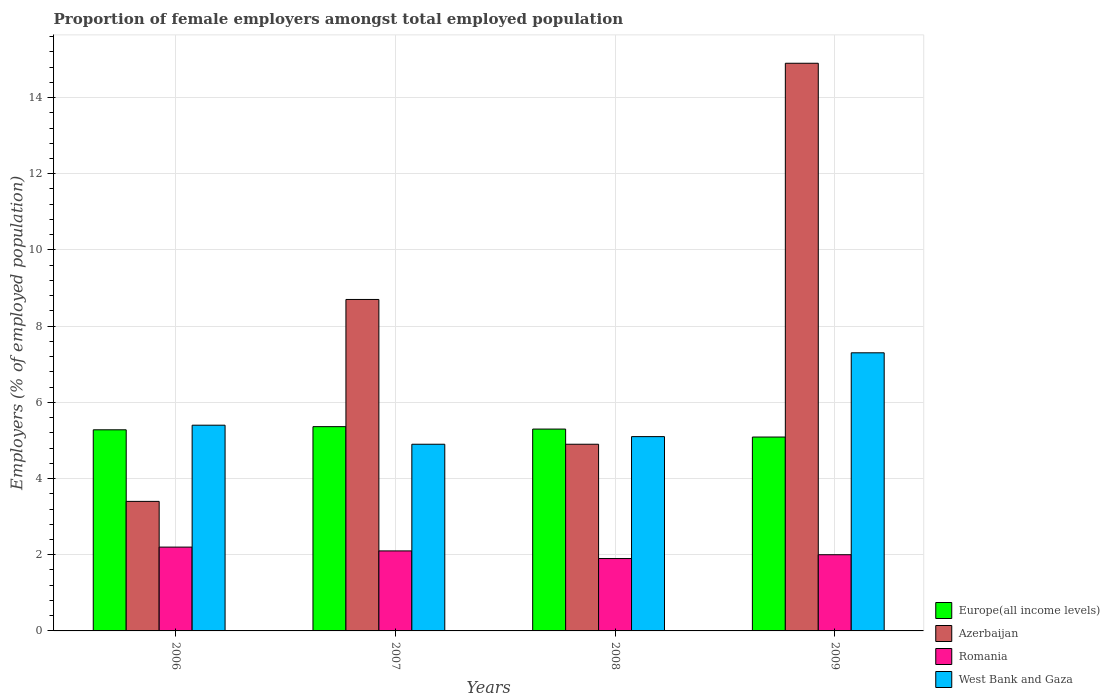How many different coloured bars are there?
Give a very brief answer. 4. How many groups of bars are there?
Keep it short and to the point. 4. How many bars are there on the 1st tick from the left?
Your answer should be very brief. 4. How many bars are there on the 4th tick from the right?
Give a very brief answer. 4. What is the label of the 1st group of bars from the left?
Ensure brevity in your answer.  2006. In how many cases, is the number of bars for a given year not equal to the number of legend labels?
Provide a short and direct response. 0. What is the proportion of female employers in Azerbaijan in 2008?
Ensure brevity in your answer.  4.9. Across all years, what is the maximum proportion of female employers in Azerbaijan?
Ensure brevity in your answer.  14.9. Across all years, what is the minimum proportion of female employers in Romania?
Make the answer very short. 1.9. In which year was the proportion of female employers in Europe(all income levels) minimum?
Your response must be concise. 2009. What is the total proportion of female employers in Europe(all income levels) in the graph?
Ensure brevity in your answer.  21.03. What is the difference between the proportion of female employers in West Bank and Gaza in 2007 and that in 2009?
Offer a very short reply. -2.4. What is the difference between the proportion of female employers in Romania in 2008 and the proportion of female employers in West Bank and Gaza in 2009?
Keep it short and to the point. -5.4. What is the average proportion of female employers in Europe(all income levels) per year?
Your response must be concise. 5.26. In the year 2006, what is the difference between the proportion of female employers in Romania and proportion of female employers in Europe(all income levels)?
Provide a succinct answer. -3.08. What is the ratio of the proportion of female employers in Romania in 2006 to that in 2007?
Keep it short and to the point. 1.05. What is the difference between the highest and the second highest proportion of female employers in Europe(all income levels)?
Your answer should be very brief. 0.06. What is the difference between the highest and the lowest proportion of female employers in West Bank and Gaza?
Keep it short and to the point. 2.4. In how many years, is the proportion of female employers in West Bank and Gaza greater than the average proportion of female employers in West Bank and Gaza taken over all years?
Keep it short and to the point. 1. Is the sum of the proportion of female employers in Azerbaijan in 2006 and 2009 greater than the maximum proportion of female employers in West Bank and Gaza across all years?
Make the answer very short. Yes. Is it the case that in every year, the sum of the proportion of female employers in West Bank and Gaza and proportion of female employers in Europe(all income levels) is greater than the sum of proportion of female employers in Romania and proportion of female employers in Azerbaijan?
Provide a succinct answer. No. What does the 1st bar from the left in 2006 represents?
Provide a succinct answer. Europe(all income levels). What does the 2nd bar from the right in 2007 represents?
Offer a terse response. Romania. How many bars are there?
Ensure brevity in your answer.  16. How many years are there in the graph?
Provide a short and direct response. 4. What is the difference between two consecutive major ticks on the Y-axis?
Provide a succinct answer. 2. Are the values on the major ticks of Y-axis written in scientific E-notation?
Your answer should be compact. No. Does the graph contain any zero values?
Your answer should be compact. No. Does the graph contain grids?
Provide a short and direct response. Yes. How many legend labels are there?
Your answer should be compact. 4. How are the legend labels stacked?
Ensure brevity in your answer.  Vertical. What is the title of the graph?
Your answer should be compact. Proportion of female employers amongst total employed population. What is the label or title of the X-axis?
Your answer should be very brief. Years. What is the label or title of the Y-axis?
Offer a very short reply. Employers (% of employed population). What is the Employers (% of employed population) of Europe(all income levels) in 2006?
Provide a short and direct response. 5.28. What is the Employers (% of employed population) of Azerbaijan in 2006?
Ensure brevity in your answer.  3.4. What is the Employers (% of employed population) of Romania in 2006?
Give a very brief answer. 2.2. What is the Employers (% of employed population) in West Bank and Gaza in 2006?
Keep it short and to the point. 5.4. What is the Employers (% of employed population) of Europe(all income levels) in 2007?
Offer a terse response. 5.36. What is the Employers (% of employed population) in Azerbaijan in 2007?
Your response must be concise. 8.7. What is the Employers (% of employed population) of Romania in 2007?
Your answer should be very brief. 2.1. What is the Employers (% of employed population) of West Bank and Gaza in 2007?
Ensure brevity in your answer.  4.9. What is the Employers (% of employed population) in Europe(all income levels) in 2008?
Offer a terse response. 5.3. What is the Employers (% of employed population) of Azerbaijan in 2008?
Give a very brief answer. 4.9. What is the Employers (% of employed population) of Romania in 2008?
Ensure brevity in your answer.  1.9. What is the Employers (% of employed population) in West Bank and Gaza in 2008?
Offer a terse response. 5.1. What is the Employers (% of employed population) in Europe(all income levels) in 2009?
Your answer should be very brief. 5.09. What is the Employers (% of employed population) of Azerbaijan in 2009?
Offer a very short reply. 14.9. What is the Employers (% of employed population) of Romania in 2009?
Provide a short and direct response. 2. What is the Employers (% of employed population) in West Bank and Gaza in 2009?
Ensure brevity in your answer.  7.3. Across all years, what is the maximum Employers (% of employed population) of Europe(all income levels)?
Ensure brevity in your answer.  5.36. Across all years, what is the maximum Employers (% of employed population) of Azerbaijan?
Keep it short and to the point. 14.9. Across all years, what is the maximum Employers (% of employed population) in Romania?
Your answer should be compact. 2.2. Across all years, what is the maximum Employers (% of employed population) in West Bank and Gaza?
Your response must be concise. 7.3. Across all years, what is the minimum Employers (% of employed population) in Europe(all income levels)?
Your answer should be compact. 5.09. Across all years, what is the minimum Employers (% of employed population) of Azerbaijan?
Give a very brief answer. 3.4. Across all years, what is the minimum Employers (% of employed population) in Romania?
Ensure brevity in your answer.  1.9. Across all years, what is the minimum Employers (% of employed population) of West Bank and Gaza?
Offer a terse response. 4.9. What is the total Employers (% of employed population) of Europe(all income levels) in the graph?
Provide a short and direct response. 21.03. What is the total Employers (% of employed population) in Azerbaijan in the graph?
Make the answer very short. 31.9. What is the total Employers (% of employed population) in Romania in the graph?
Your response must be concise. 8.2. What is the total Employers (% of employed population) of West Bank and Gaza in the graph?
Provide a succinct answer. 22.7. What is the difference between the Employers (% of employed population) in Europe(all income levels) in 2006 and that in 2007?
Keep it short and to the point. -0.08. What is the difference between the Employers (% of employed population) in Azerbaijan in 2006 and that in 2007?
Keep it short and to the point. -5.3. What is the difference between the Employers (% of employed population) in Romania in 2006 and that in 2007?
Ensure brevity in your answer.  0.1. What is the difference between the Employers (% of employed population) in West Bank and Gaza in 2006 and that in 2007?
Keep it short and to the point. 0.5. What is the difference between the Employers (% of employed population) of Europe(all income levels) in 2006 and that in 2008?
Offer a terse response. -0.02. What is the difference between the Employers (% of employed population) of Azerbaijan in 2006 and that in 2008?
Offer a very short reply. -1.5. What is the difference between the Employers (% of employed population) in West Bank and Gaza in 2006 and that in 2008?
Provide a short and direct response. 0.3. What is the difference between the Employers (% of employed population) of Europe(all income levels) in 2006 and that in 2009?
Provide a succinct answer. 0.19. What is the difference between the Employers (% of employed population) in Romania in 2006 and that in 2009?
Offer a very short reply. 0.2. What is the difference between the Employers (% of employed population) of Europe(all income levels) in 2007 and that in 2008?
Your answer should be compact. 0.06. What is the difference between the Employers (% of employed population) in Azerbaijan in 2007 and that in 2008?
Provide a short and direct response. 3.8. What is the difference between the Employers (% of employed population) in Romania in 2007 and that in 2008?
Keep it short and to the point. 0.2. What is the difference between the Employers (% of employed population) of Europe(all income levels) in 2007 and that in 2009?
Offer a terse response. 0.27. What is the difference between the Employers (% of employed population) in Europe(all income levels) in 2008 and that in 2009?
Provide a succinct answer. 0.21. What is the difference between the Employers (% of employed population) of Europe(all income levels) in 2006 and the Employers (% of employed population) of Azerbaijan in 2007?
Provide a short and direct response. -3.42. What is the difference between the Employers (% of employed population) of Europe(all income levels) in 2006 and the Employers (% of employed population) of Romania in 2007?
Offer a very short reply. 3.18. What is the difference between the Employers (% of employed population) in Europe(all income levels) in 2006 and the Employers (% of employed population) in West Bank and Gaza in 2007?
Make the answer very short. 0.38. What is the difference between the Employers (% of employed population) of Europe(all income levels) in 2006 and the Employers (% of employed population) of Azerbaijan in 2008?
Provide a succinct answer. 0.38. What is the difference between the Employers (% of employed population) in Europe(all income levels) in 2006 and the Employers (% of employed population) in Romania in 2008?
Your answer should be very brief. 3.38. What is the difference between the Employers (% of employed population) of Europe(all income levels) in 2006 and the Employers (% of employed population) of West Bank and Gaza in 2008?
Ensure brevity in your answer.  0.18. What is the difference between the Employers (% of employed population) in Romania in 2006 and the Employers (% of employed population) in West Bank and Gaza in 2008?
Offer a terse response. -2.9. What is the difference between the Employers (% of employed population) of Europe(all income levels) in 2006 and the Employers (% of employed population) of Azerbaijan in 2009?
Your answer should be compact. -9.62. What is the difference between the Employers (% of employed population) in Europe(all income levels) in 2006 and the Employers (% of employed population) in Romania in 2009?
Provide a succinct answer. 3.28. What is the difference between the Employers (% of employed population) in Europe(all income levels) in 2006 and the Employers (% of employed population) in West Bank and Gaza in 2009?
Keep it short and to the point. -2.02. What is the difference between the Employers (% of employed population) in Azerbaijan in 2006 and the Employers (% of employed population) in Romania in 2009?
Provide a succinct answer. 1.4. What is the difference between the Employers (% of employed population) in Azerbaijan in 2006 and the Employers (% of employed population) in West Bank and Gaza in 2009?
Provide a succinct answer. -3.9. What is the difference between the Employers (% of employed population) in Romania in 2006 and the Employers (% of employed population) in West Bank and Gaza in 2009?
Offer a very short reply. -5.1. What is the difference between the Employers (% of employed population) of Europe(all income levels) in 2007 and the Employers (% of employed population) of Azerbaijan in 2008?
Provide a short and direct response. 0.46. What is the difference between the Employers (% of employed population) in Europe(all income levels) in 2007 and the Employers (% of employed population) in Romania in 2008?
Keep it short and to the point. 3.46. What is the difference between the Employers (% of employed population) of Europe(all income levels) in 2007 and the Employers (% of employed population) of West Bank and Gaza in 2008?
Provide a succinct answer. 0.26. What is the difference between the Employers (% of employed population) in Europe(all income levels) in 2007 and the Employers (% of employed population) in Azerbaijan in 2009?
Provide a succinct answer. -9.54. What is the difference between the Employers (% of employed population) in Europe(all income levels) in 2007 and the Employers (% of employed population) in Romania in 2009?
Make the answer very short. 3.36. What is the difference between the Employers (% of employed population) in Europe(all income levels) in 2007 and the Employers (% of employed population) in West Bank and Gaza in 2009?
Ensure brevity in your answer.  -1.94. What is the difference between the Employers (% of employed population) in Europe(all income levels) in 2008 and the Employers (% of employed population) in Azerbaijan in 2009?
Give a very brief answer. -9.6. What is the difference between the Employers (% of employed population) in Europe(all income levels) in 2008 and the Employers (% of employed population) in Romania in 2009?
Make the answer very short. 3.3. What is the difference between the Employers (% of employed population) in Europe(all income levels) in 2008 and the Employers (% of employed population) in West Bank and Gaza in 2009?
Offer a very short reply. -2. What is the average Employers (% of employed population) of Europe(all income levels) per year?
Offer a very short reply. 5.26. What is the average Employers (% of employed population) in Azerbaijan per year?
Ensure brevity in your answer.  7.97. What is the average Employers (% of employed population) of Romania per year?
Offer a very short reply. 2.05. What is the average Employers (% of employed population) of West Bank and Gaza per year?
Provide a short and direct response. 5.67. In the year 2006, what is the difference between the Employers (% of employed population) in Europe(all income levels) and Employers (% of employed population) in Azerbaijan?
Keep it short and to the point. 1.88. In the year 2006, what is the difference between the Employers (% of employed population) in Europe(all income levels) and Employers (% of employed population) in Romania?
Provide a succinct answer. 3.08. In the year 2006, what is the difference between the Employers (% of employed population) in Europe(all income levels) and Employers (% of employed population) in West Bank and Gaza?
Your response must be concise. -0.12. In the year 2007, what is the difference between the Employers (% of employed population) in Europe(all income levels) and Employers (% of employed population) in Azerbaijan?
Offer a terse response. -3.34. In the year 2007, what is the difference between the Employers (% of employed population) of Europe(all income levels) and Employers (% of employed population) of Romania?
Keep it short and to the point. 3.26. In the year 2007, what is the difference between the Employers (% of employed population) in Europe(all income levels) and Employers (% of employed population) in West Bank and Gaza?
Keep it short and to the point. 0.46. In the year 2007, what is the difference between the Employers (% of employed population) of Azerbaijan and Employers (% of employed population) of West Bank and Gaza?
Make the answer very short. 3.8. In the year 2008, what is the difference between the Employers (% of employed population) of Europe(all income levels) and Employers (% of employed population) of Azerbaijan?
Give a very brief answer. 0.4. In the year 2008, what is the difference between the Employers (% of employed population) in Europe(all income levels) and Employers (% of employed population) in Romania?
Provide a short and direct response. 3.4. In the year 2008, what is the difference between the Employers (% of employed population) of Europe(all income levels) and Employers (% of employed population) of West Bank and Gaza?
Your answer should be compact. 0.2. In the year 2008, what is the difference between the Employers (% of employed population) of Azerbaijan and Employers (% of employed population) of West Bank and Gaza?
Make the answer very short. -0.2. In the year 2009, what is the difference between the Employers (% of employed population) in Europe(all income levels) and Employers (% of employed population) in Azerbaijan?
Offer a terse response. -9.81. In the year 2009, what is the difference between the Employers (% of employed population) of Europe(all income levels) and Employers (% of employed population) of Romania?
Offer a terse response. 3.09. In the year 2009, what is the difference between the Employers (% of employed population) in Europe(all income levels) and Employers (% of employed population) in West Bank and Gaza?
Your response must be concise. -2.21. In the year 2009, what is the difference between the Employers (% of employed population) in Azerbaijan and Employers (% of employed population) in Romania?
Offer a very short reply. 12.9. In the year 2009, what is the difference between the Employers (% of employed population) in Romania and Employers (% of employed population) in West Bank and Gaza?
Provide a succinct answer. -5.3. What is the ratio of the Employers (% of employed population) in Europe(all income levels) in 2006 to that in 2007?
Provide a succinct answer. 0.98. What is the ratio of the Employers (% of employed population) in Azerbaijan in 2006 to that in 2007?
Give a very brief answer. 0.39. What is the ratio of the Employers (% of employed population) in Romania in 2006 to that in 2007?
Ensure brevity in your answer.  1.05. What is the ratio of the Employers (% of employed population) of West Bank and Gaza in 2006 to that in 2007?
Offer a very short reply. 1.1. What is the ratio of the Employers (% of employed population) in Azerbaijan in 2006 to that in 2008?
Make the answer very short. 0.69. What is the ratio of the Employers (% of employed population) in Romania in 2006 to that in 2008?
Ensure brevity in your answer.  1.16. What is the ratio of the Employers (% of employed population) of West Bank and Gaza in 2006 to that in 2008?
Ensure brevity in your answer.  1.06. What is the ratio of the Employers (% of employed population) of Europe(all income levels) in 2006 to that in 2009?
Your answer should be compact. 1.04. What is the ratio of the Employers (% of employed population) of Azerbaijan in 2006 to that in 2009?
Your answer should be very brief. 0.23. What is the ratio of the Employers (% of employed population) in Romania in 2006 to that in 2009?
Provide a succinct answer. 1.1. What is the ratio of the Employers (% of employed population) of West Bank and Gaza in 2006 to that in 2009?
Give a very brief answer. 0.74. What is the ratio of the Employers (% of employed population) of Europe(all income levels) in 2007 to that in 2008?
Offer a very short reply. 1.01. What is the ratio of the Employers (% of employed population) of Azerbaijan in 2007 to that in 2008?
Provide a short and direct response. 1.78. What is the ratio of the Employers (% of employed population) in Romania in 2007 to that in 2008?
Make the answer very short. 1.11. What is the ratio of the Employers (% of employed population) of West Bank and Gaza in 2007 to that in 2008?
Provide a short and direct response. 0.96. What is the ratio of the Employers (% of employed population) of Europe(all income levels) in 2007 to that in 2009?
Ensure brevity in your answer.  1.05. What is the ratio of the Employers (% of employed population) of Azerbaijan in 2007 to that in 2009?
Your response must be concise. 0.58. What is the ratio of the Employers (% of employed population) of Romania in 2007 to that in 2009?
Provide a short and direct response. 1.05. What is the ratio of the Employers (% of employed population) of West Bank and Gaza in 2007 to that in 2009?
Keep it short and to the point. 0.67. What is the ratio of the Employers (% of employed population) of Europe(all income levels) in 2008 to that in 2009?
Offer a very short reply. 1.04. What is the ratio of the Employers (% of employed population) of Azerbaijan in 2008 to that in 2009?
Your response must be concise. 0.33. What is the ratio of the Employers (% of employed population) of Romania in 2008 to that in 2009?
Provide a succinct answer. 0.95. What is the ratio of the Employers (% of employed population) in West Bank and Gaza in 2008 to that in 2009?
Make the answer very short. 0.7. What is the difference between the highest and the second highest Employers (% of employed population) of Europe(all income levels)?
Offer a very short reply. 0.06. What is the difference between the highest and the second highest Employers (% of employed population) in Azerbaijan?
Make the answer very short. 6.2. What is the difference between the highest and the second highest Employers (% of employed population) in Romania?
Provide a succinct answer. 0.1. What is the difference between the highest and the second highest Employers (% of employed population) in West Bank and Gaza?
Provide a short and direct response. 1.9. What is the difference between the highest and the lowest Employers (% of employed population) in Europe(all income levels)?
Provide a succinct answer. 0.27. 